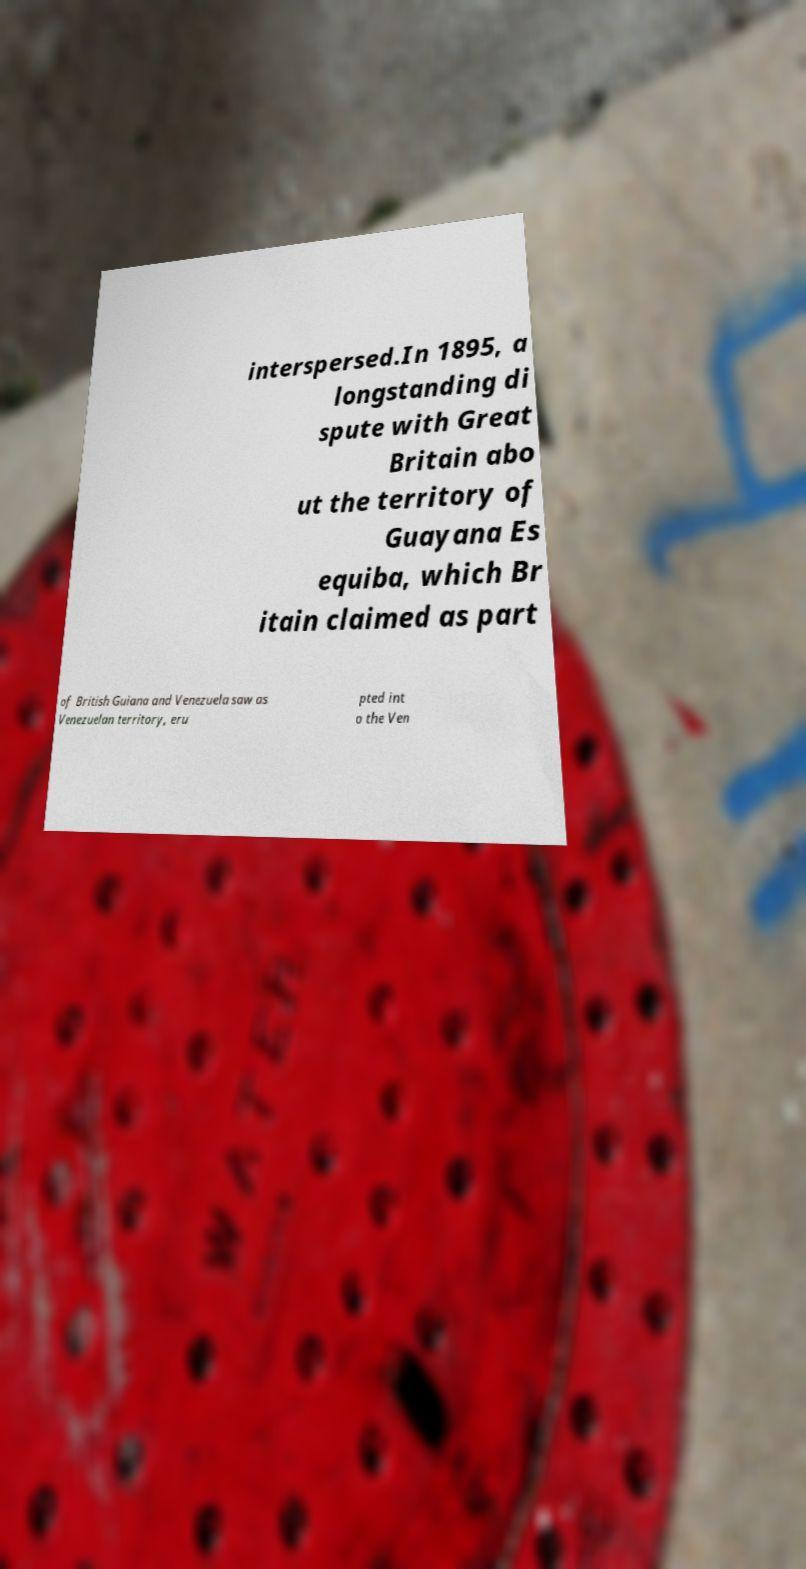Can you accurately transcribe the text from the provided image for me? interspersed.In 1895, a longstanding di spute with Great Britain abo ut the territory of Guayana Es equiba, which Br itain claimed as part of British Guiana and Venezuela saw as Venezuelan territory, eru pted int o the Ven 